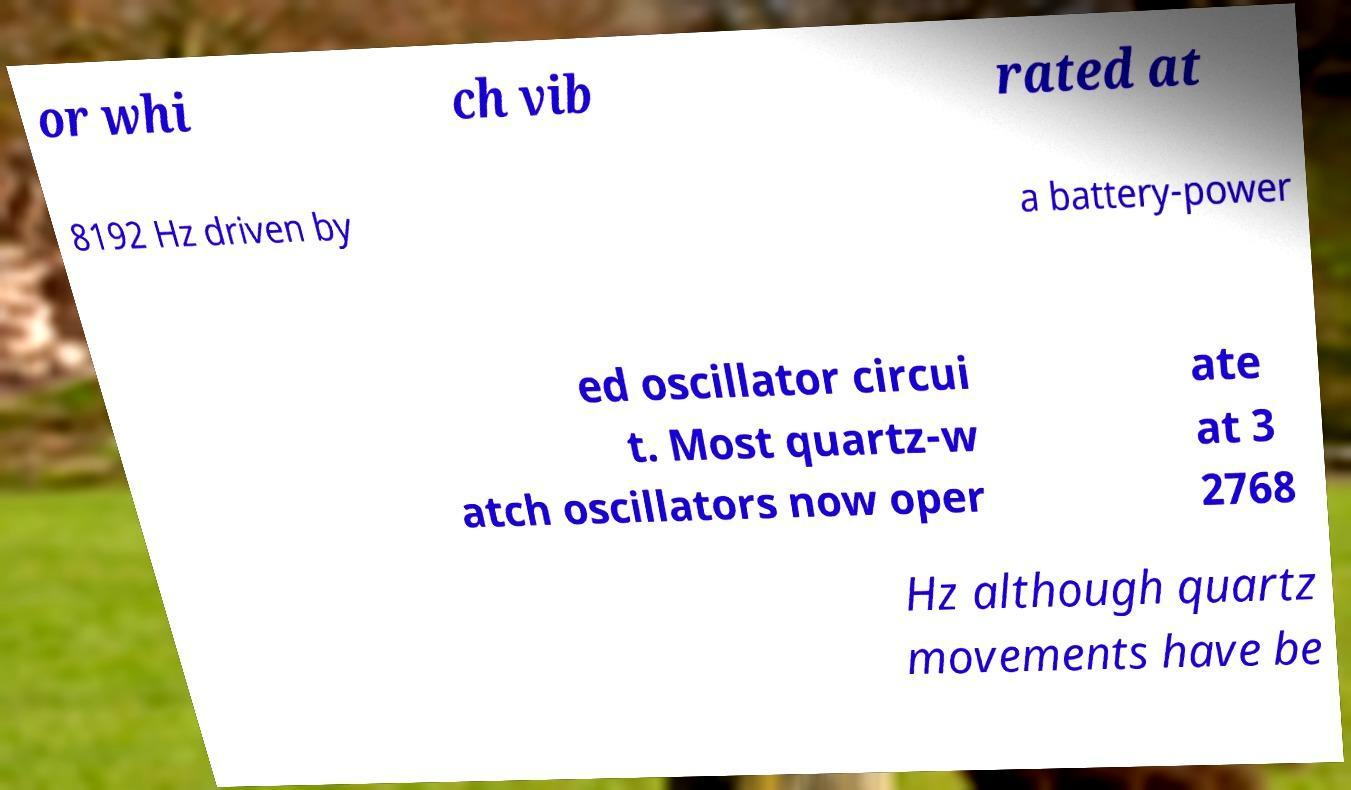Can you read and provide the text displayed in the image?This photo seems to have some interesting text. Can you extract and type it out for me? or whi ch vib rated at 8192 Hz driven by a battery-power ed oscillator circui t. Most quartz-w atch oscillators now oper ate at 3 2768 Hz although quartz movements have be 